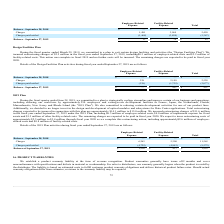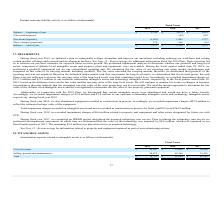From Macom Technology's financial document, What was the (Divested)/acquired values in 2019, 2018 and 2017 respectively? The document contains multiple relevant values: —, (49), 952 (in thousands). From the document: "(Divested)/acquired — (49) 952 (Divested)/acquired — (49) 952 (Divested)/acquired — (49) 952..." Also, What was the Balance — beginning of year in 2018? According to the financial document, $3,672 (in thousands). The relevant text states: "Balance — beginning of year $ 5,756 $ 3,672 $ 1,039..." Also, What was the Balance — beginning of year in 2019? According to the financial document, $5,756 (in thousands). The relevant text states: "Balance — beginning of year $ 5,756 $ 3,672 $ 1,039..." Additionally, In which year was Balance — beginning of year less than 5,000 thousands? The document shows two values: 2018 and 2017. Locate and analyze balance — beginning of year in row 3. From the document: "2019 2018 2017 2019 2018 2017..." Also, can you calculate: What was the change in the Provisions/(expense) from 2017 to 2018? Based on the calculation: 1,865 - 1,737, the result is 128 (in thousands). This is based on the information: "Provisions/(expense) (3,053) 1,865 1,737 Provisions/(expense) (3,053) 1,865 1,737..." The key data points involved are: 1,737, 1,865. Also, can you calculate: What is the average Direct charges/(payments) for 2017-2019? To answer this question, I need to perform calculations using the financial data. The calculation is: (570 + 268 - 56) / 3, which equals 260.67 (in thousands). This is based on the information: "Direct charges/(payments) 570 268 (56) Direct charges/(payments) 570 268 (56) Direct charges/(payments) 570 268 (56)..." The key data points involved are: 268, 56, 570. 